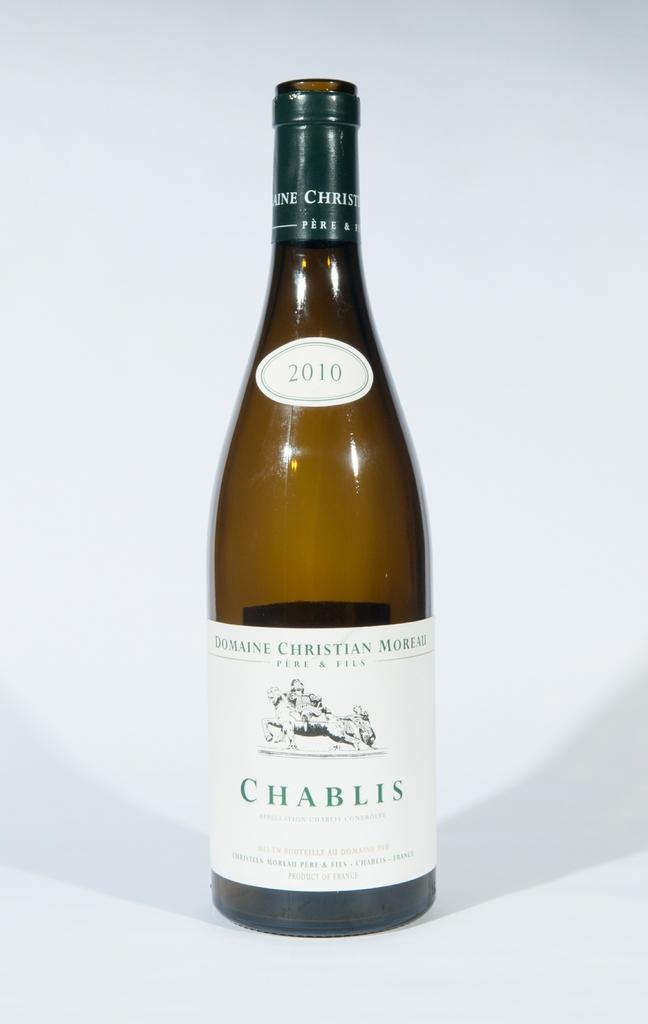Is this a bottle of chablis?
Offer a terse response. Yes. What year was the chablis made in?
Your answer should be compact. 2010. 